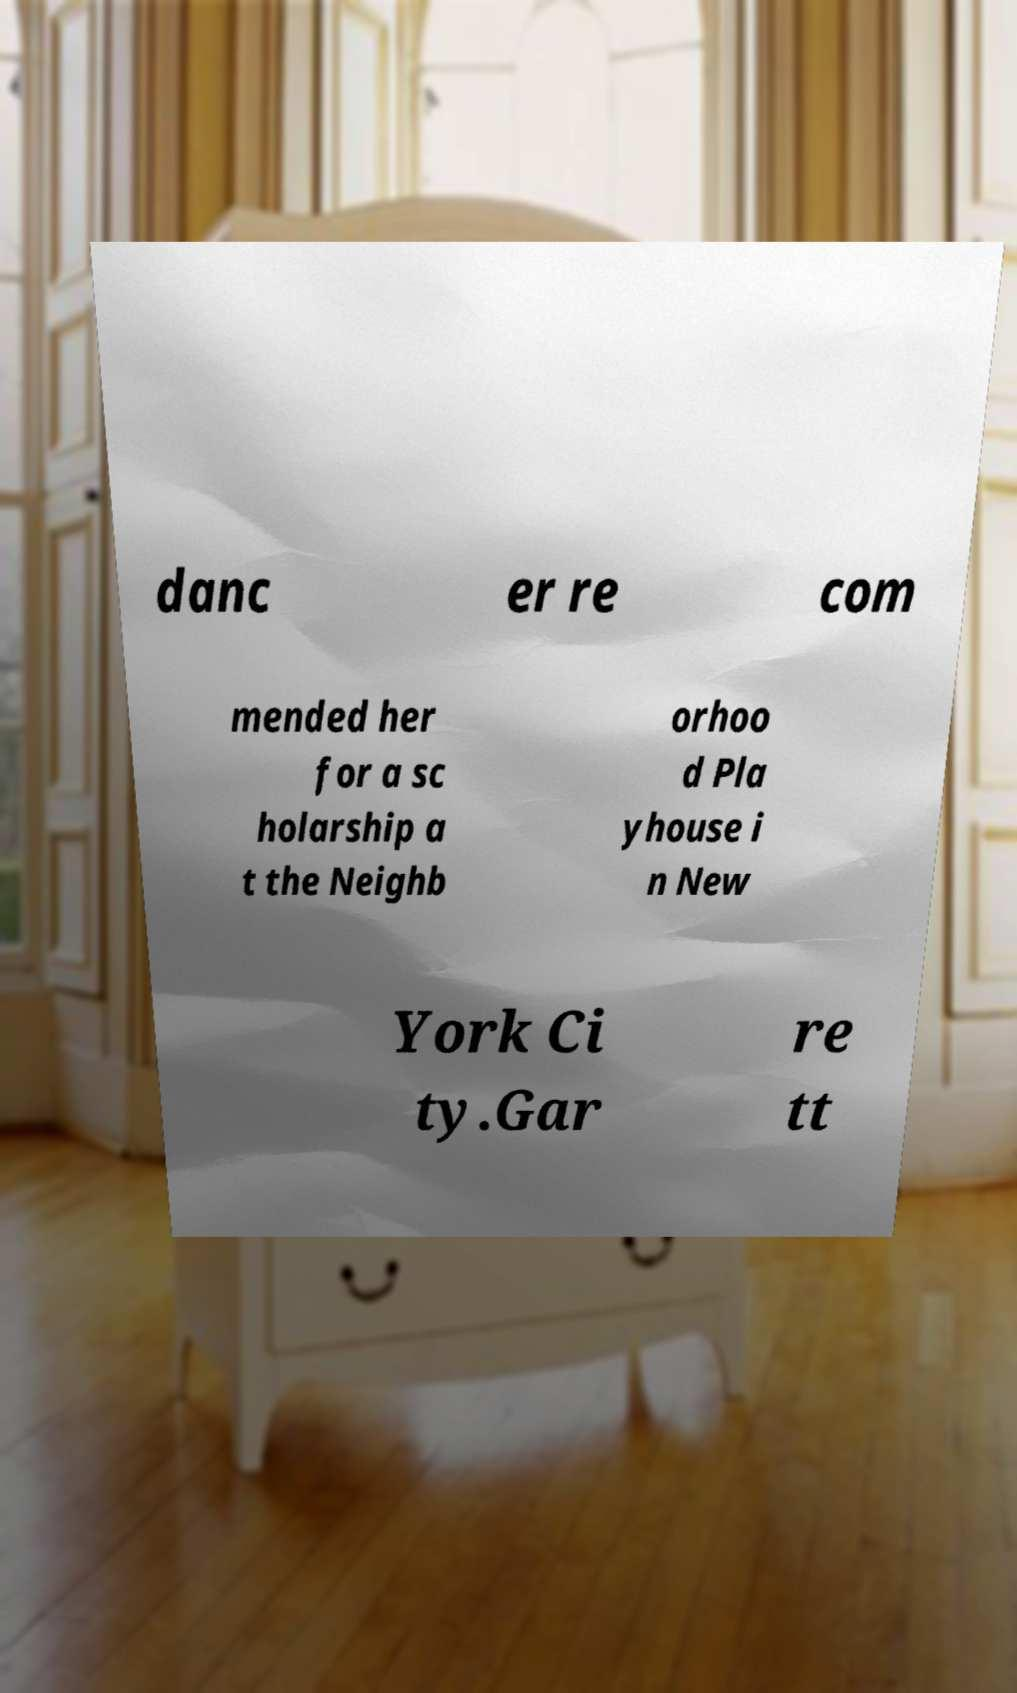Can you accurately transcribe the text from the provided image for me? danc er re com mended her for a sc holarship a t the Neighb orhoo d Pla yhouse i n New York Ci ty.Gar re tt 